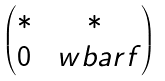Convert formula to latex. <formula><loc_0><loc_0><loc_500><loc_500>\begin{pmatrix} * & * \\ 0 & \ w b a r f \end{pmatrix}</formula> 